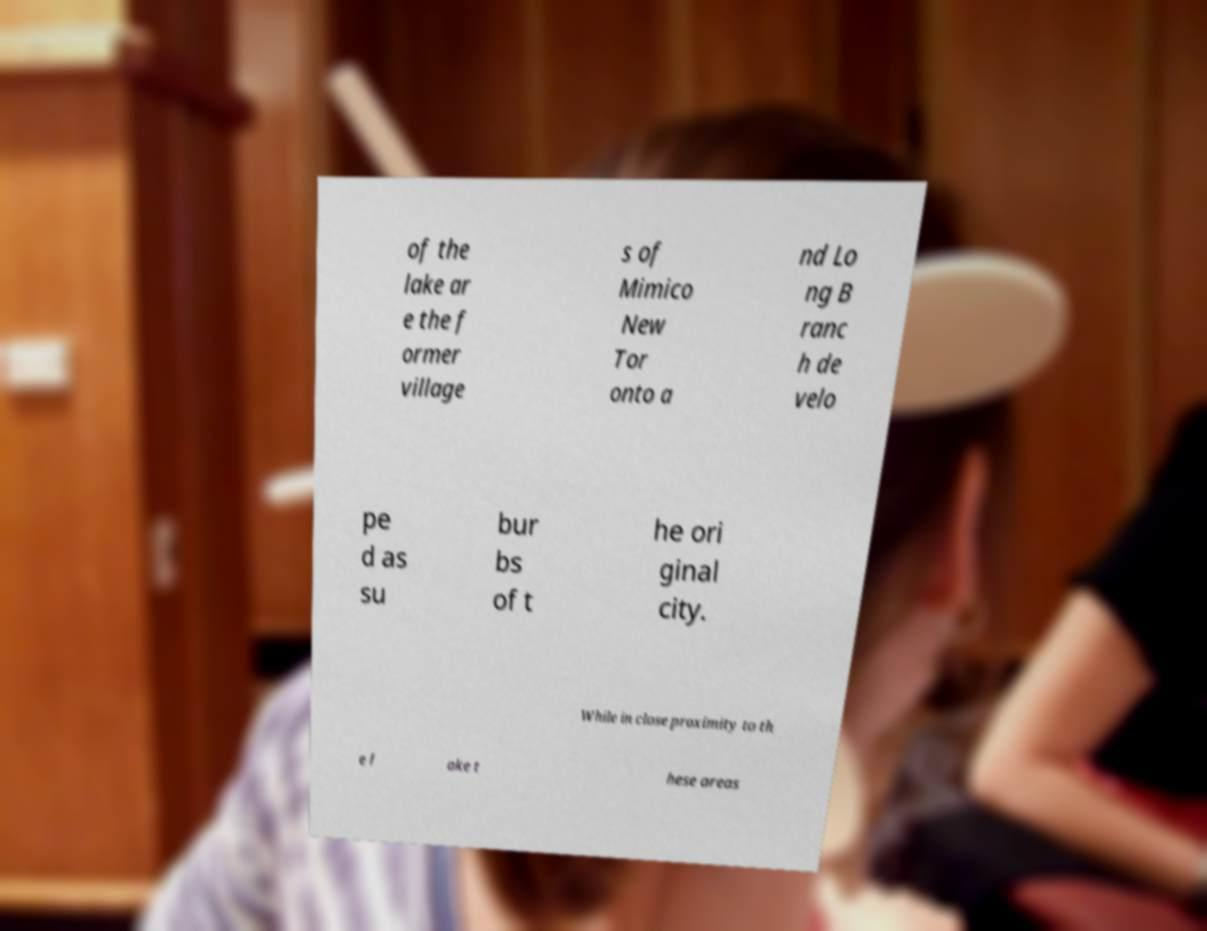Please identify and transcribe the text found in this image. of the lake ar e the f ormer village s of Mimico New Tor onto a nd Lo ng B ranc h de velo pe d as su bur bs of t he ori ginal city. While in close proximity to th e l ake t hese areas 